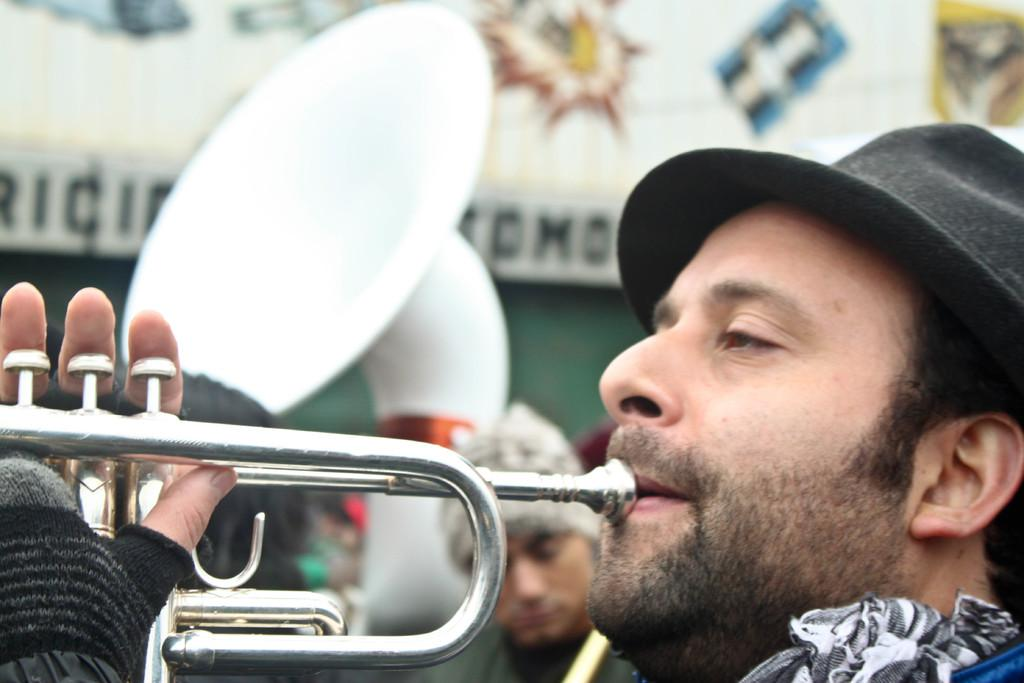What is the main subject of the image? There is a person in the image. What is the person doing in the image? The person is playing a music instrument. Can you describe the background of the image? The background of the person is blurred. What is the aftermath of the head injury in the image? There is no indication of a head injury or any aftermath in the image. 